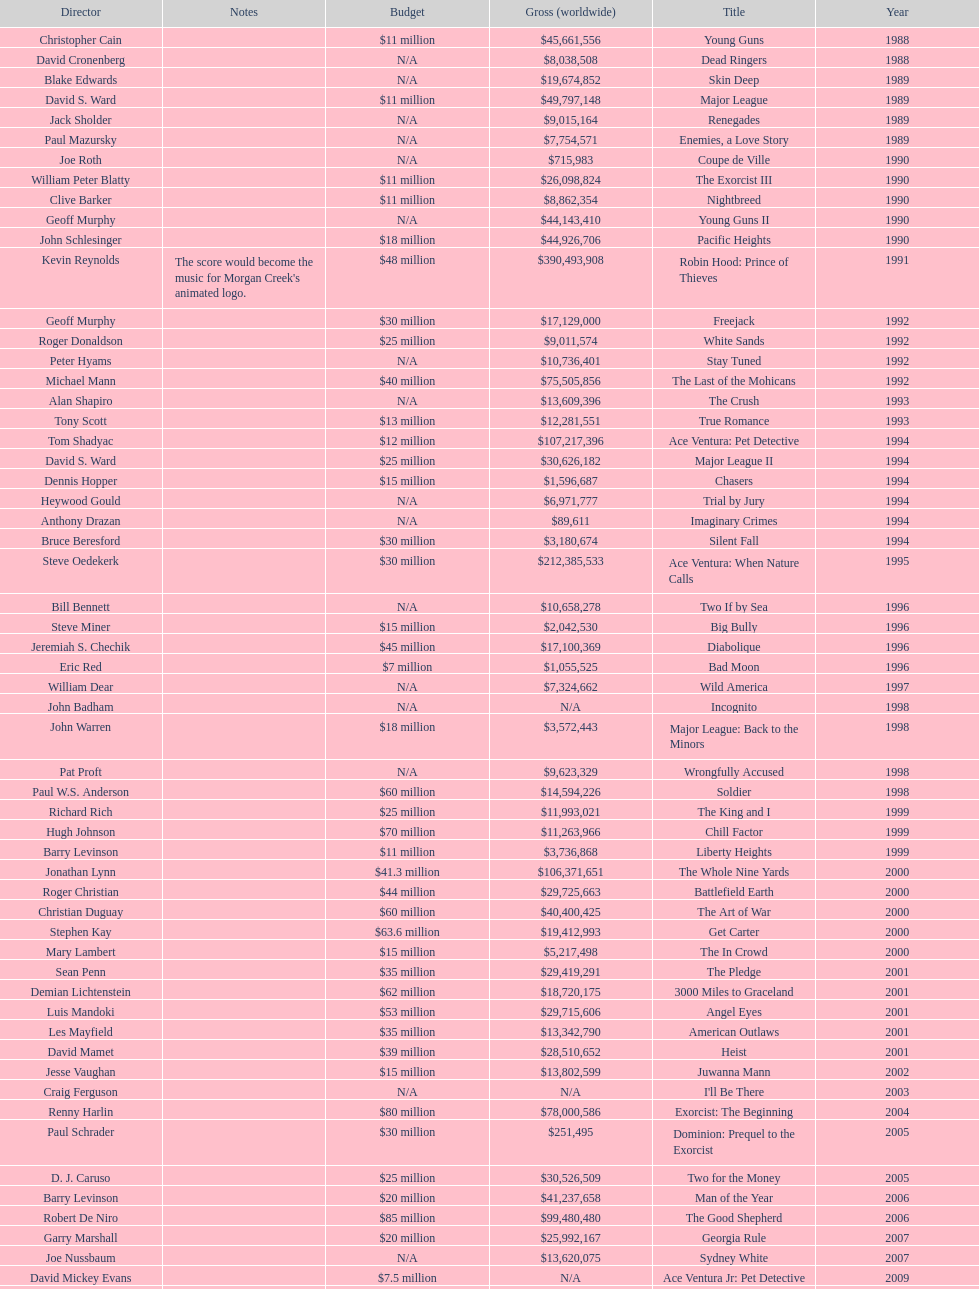Which morgan creek film grossed the most money prior to 1994? Robin Hood: Prince of Thieves. 